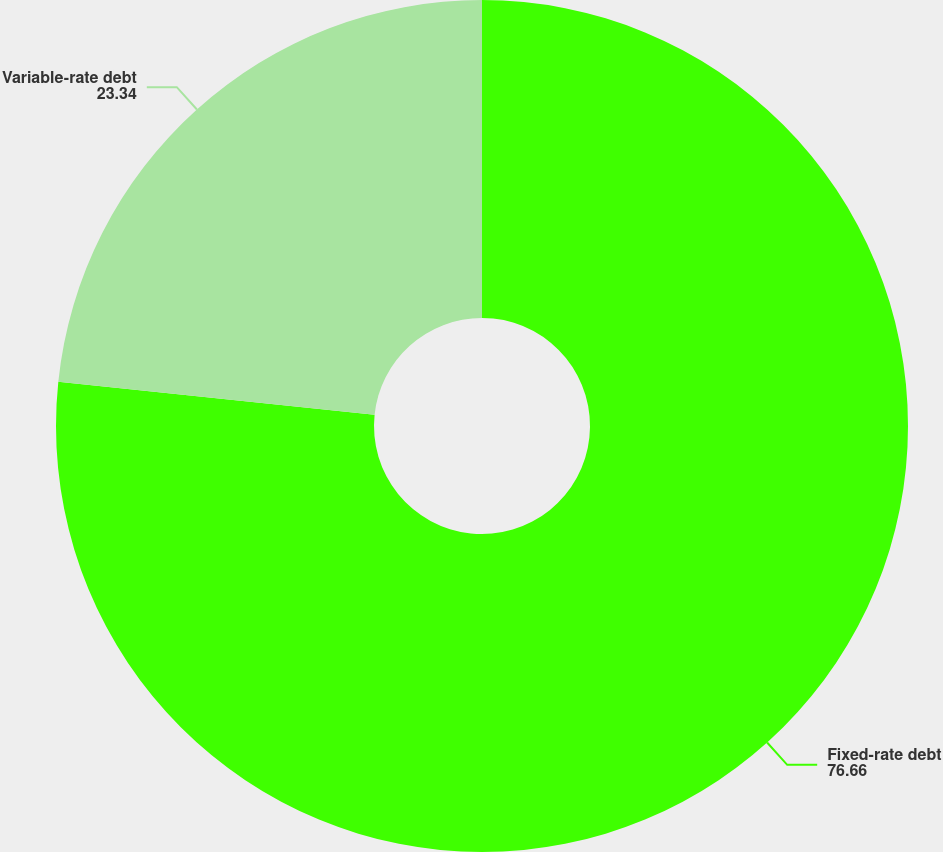Convert chart to OTSL. <chart><loc_0><loc_0><loc_500><loc_500><pie_chart><fcel>Fixed-rate debt<fcel>Variable-rate debt<nl><fcel>76.66%<fcel>23.34%<nl></chart> 